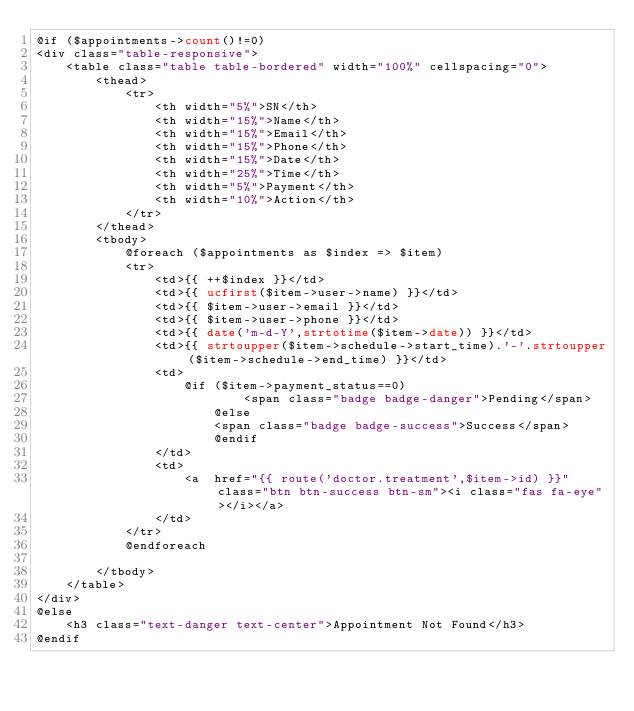Convert code to text. <code><loc_0><loc_0><loc_500><loc_500><_PHP_>@if ($appointments->count()!=0)
<div class="table-responsive">
    <table class="table table-bordered" width="100%" cellspacing="0">
        <thead>
            <tr>
                <th width="5%">SN</th>
                <th width="15%">Name</th>
                <th width="15%">Email</th>
                <th width="15%">Phone</th>
                <th width="15%">Date</th>
                <th width="25%">Time</th>
                <th width="5%">Payment</th>
                <th width="10%">Action</th>
            </tr>
        </thead>
        <tbody>
            @foreach ($appointments as $index => $item)
            <tr>
                <td>{{ ++$index }}</td>
                <td>{{ ucfirst($item->user->name) }}</td>
                <td>{{ $item->user->email }}</td>
                <td>{{ $item->user->phone }}</td>
                <td>{{ date('m-d-Y',strtotime($item->date)) }}</td>
                <td>{{ strtoupper($item->schedule->start_time).'-'.strtoupper($item->schedule->end_time) }}</td>
                <td>
                    @if ($item->payment_status==0)
                            <span class="badge badge-danger">Pending</span>
                        @else
                        <span class="badge badge-success">Success</span>
                        @endif
                </td>
                <td>
                    <a  href="{{ route('doctor.treatment',$item->id) }}" class="btn btn-success btn-sm"><i class="fas fa-eye"></i></a>
                </td>
            </tr>
            @endforeach

        </tbody>
    </table>
</div>
@else
    <h3 class="text-danger text-center">Appointment Not Found</h3>
@endif
</code> 